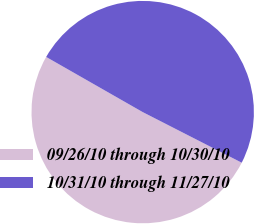<chart> <loc_0><loc_0><loc_500><loc_500><pie_chart><fcel>09/26/10 through 10/30/10<fcel>10/31/10 through 11/27/10<nl><fcel>50.74%<fcel>49.26%<nl></chart> 